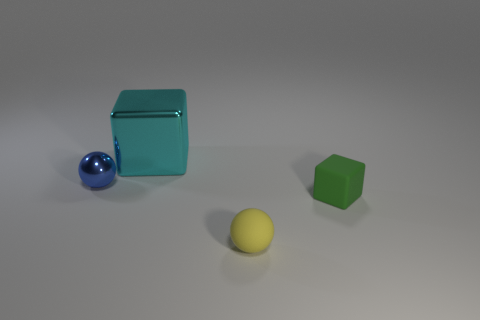Subtract all red spheres. Subtract all red cylinders. How many spheres are left? 2 Add 3 cyan things. How many objects exist? 7 Add 2 yellow rubber things. How many yellow rubber things are left? 3 Add 4 tiny purple shiny things. How many tiny purple shiny things exist? 4 Subtract 0 purple spheres. How many objects are left? 4 Subtract all purple matte spheres. Subtract all tiny blocks. How many objects are left? 3 